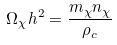Convert formula to latex. <formula><loc_0><loc_0><loc_500><loc_500>\Omega _ { \chi } h ^ { 2 } = \frac { m _ { \chi } n _ { \chi } } { \rho _ { c } }</formula> 